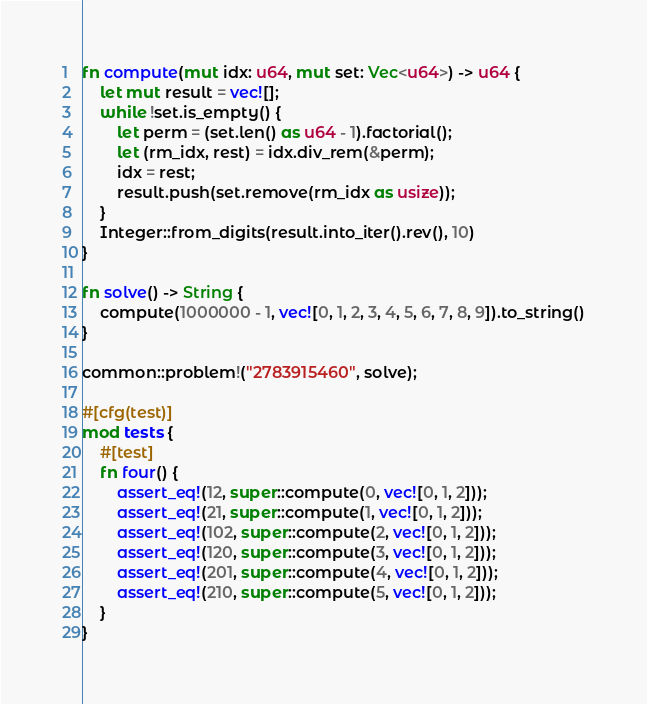<code> <loc_0><loc_0><loc_500><loc_500><_Rust_>
fn compute(mut idx: u64, mut set: Vec<u64>) -> u64 {
    let mut result = vec![];
    while !set.is_empty() {
        let perm = (set.len() as u64 - 1).factorial();
        let (rm_idx, rest) = idx.div_rem(&perm);
        idx = rest;
        result.push(set.remove(rm_idx as usize));
    }
    Integer::from_digits(result.into_iter().rev(), 10)
}

fn solve() -> String {
    compute(1000000 - 1, vec![0, 1, 2, 3, 4, 5, 6, 7, 8, 9]).to_string()
}

common::problem!("2783915460", solve);

#[cfg(test)]
mod tests {
    #[test]
    fn four() {
        assert_eq!(12, super::compute(0, vec![0, 1, 2]));
        assert_eq!(21, super::compute(1, vec![0, 1, 2]));
        assert_eq!(102, super::compute(2, vec![0, 1, 2]));
        assert_eq!(120, super::compute(3, vec![0, 1, 2]));
        assert_eq!(201, super::compute(4, vec![0, 1, 2]));
        assert_eq!(210, super::compute(5, vec![0, 1, 2]));
    }
}
</code> 